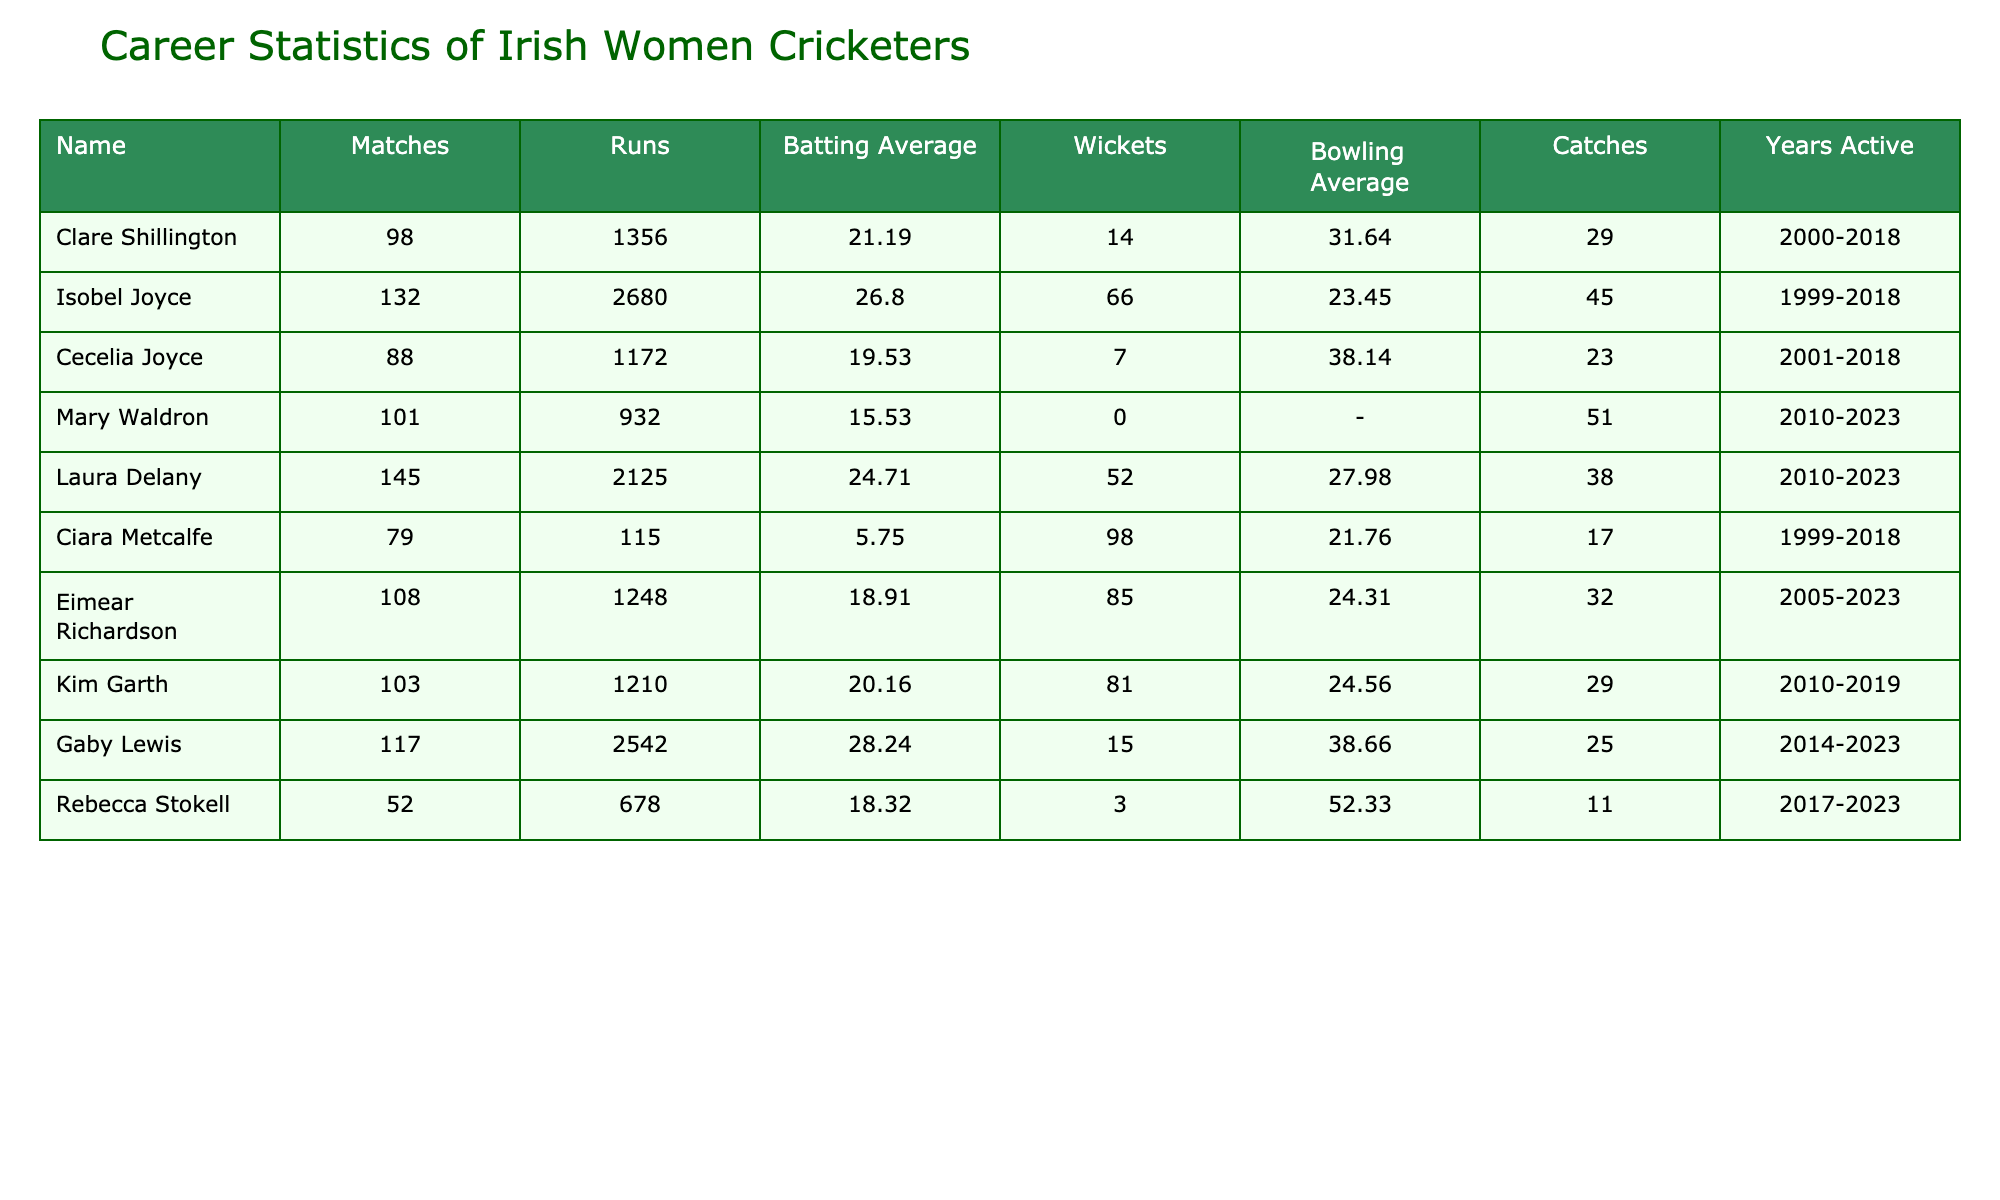What is the highest batting average among the players listed? By examining the 'Batting Average' column, Gaby Lewis has the highest average of 28.24 among the players.
Answer: 28.24 How many total runs did Isobel Joyce score in her career? Looking at the 'Runs' column, Isobel Joyce is credited with 2680 runs throughout her career.
Answer: 2680 Did Clare Shillington take more catches than Eimear Richardson? Clare Shillington took 29 catches while Eimear Richardson took 32 catches, so the statement is false.
Answer: No What is the combined number of wickets taken by Laura Delany and Kim Garth? Adding the wickets of both players: Laura Delany took 52 wickets and Kim Garth took 81 wickets; thus, 52 + 81 = 133 wickets in total.
Answer: 133 Which player has the lowest batting average? The batting averages are compared, and Ciara Metcalfe has the lowest average at 5.75, according to the table.
Answer: 5.75 How many players have taken more than 50 wickets? Reviewing the 'Wickets' column, Isobel Joyce, Ciara Metcalfe, Eimear Richardson, Kim Garth, and Clare Shillington have all taken more than 50 wickets, totaling 5 players.
Answer: 5 What is the difference in matches played between Laura Delany and Mary Waldron? Subtracting the matches played, Laura Delany played 145 matches, while Mary Waldron played 101 matches, resulting in a difference of 145 - 101 = 44 matches.
Answer: 44 Is there any player with a bowling average of less than 25? The bowling averages are examined, and Eimear Richardson has a bowling average of 24.31, indicating that there is indeed a player below 25.
Answer: Yes What percentage of catches did Clare Shillington take compared to the total catches by all players? Clare Shillington took 29 catches, and the total number of catches is 29 + 45 + 23 + 51 + 38 + 17 + 32 + 29 + 11 = 305. The percentage is (29/305)*100 = approx. 9.51%.
Answer: 9.51% Which player has the most runs and also the most wickets? By analyzing the table, Isobel Joyce has the highest number of runs (2680) and also ranks high in wickets with 66, confirming she has both the most runs and a significant wicket count.
Answer: Isobel Joyce 